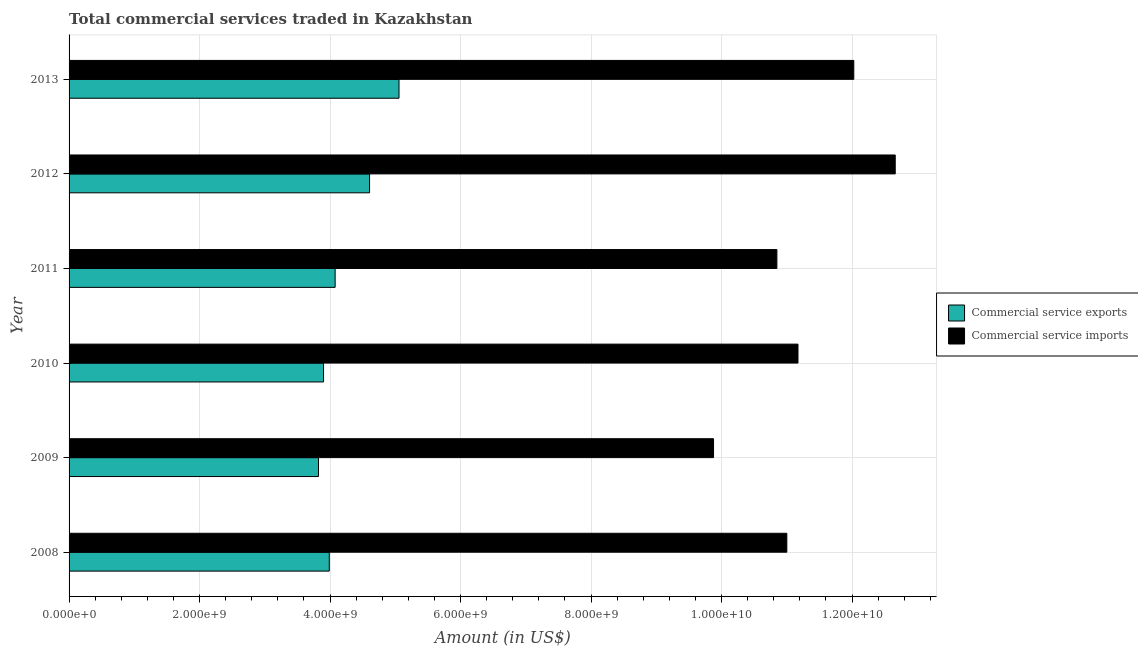In how many cases, is the number of bars for a given year not equal to the number of legend labels?
Keep it short and to the point. 0. What is the amount of commercial service exports in 2012?
Make the answer very short. 4.61e+09. Across all years, what is the maximum amount of commercial service exports?
Offer a very short reply. 5.06e+09. Across all years, what is the minimum amount of commercial service exports?
Offer a terse response. 3.82e+09. What is the total amount of commercial service imports in the graph?
Offer a very short reply. 6.76e+1. What is the difference between the amount of commercial service imports in 2009 and that in 2013?
Ensure brevity in your answer.  -2.15e+09. What is the difference between the amount of commercial service exports in 2008 and the amount of commercial service imports in 2012?
Provide a succinct answer. -8.67e+09. What is the average amount of commercial service exports per year?
Your response must be concise. 4.24e+09. In the year 2008, what is the difference between the amount of commercial service exports and amount of commercial service imports?
Your answer should be very brief. -7.01e+09. In how many years, is the amount of commercial service imports greater than 9600000000 US$?
Offer a terse response. 6. What is the ratio of the amount of commercial service exports in 2011 to that in 2012?
Your answer should be compact. 0.89. Is the amount of commercial service imports in 2012 less than that in 2013?
Provide a succinct answer. No. Is the difference between the amount of commercial service imports in 2008 and 2012 greater than the difference between the amount of commercial service exports in 2008 and 2012?
Make the answer very short. No. What is the difference between the highest and the second highest amount of commercial service imports?
Ensure brevity in your answer.  6.35e+08. What is the difference between the highest and the lowest amount of commercial service exports?
Offer a terse response. 1.23e+09. In how many years, is the amount of commercial service imports greater than the average amount of commercial service imports taken over all years?
Provide a short and direct response. 2. What does the 1st bar from the top in 2009 represents?
Offer a very short reply. Commercial service imports. What does the 2nd bar from the bottom in 2008 represents?
Give a very brief answer. Commercial service imports. Are all the bars in the graph horizontal?
Offer a terse response. Yes. How many years are there in the graph?
Give a very brief answer. 6. What is the difference between two consecutive major ticks on the X-axis?
Provide a succinct answer. 2.00e+09. Does the graph contain any zero values?
Provide a succinct answer. No. Where does the legend appear in the graph?
Your response must be concise. Center right. How many legend labels are there?
Provide a short and direct response. 2. What is the title of the graph?
Your answer should be very brief. Total commercial services traded in Kazakhstan. What is the label or title of the X-axis?
Your answer should be very brief. Amount (in US$). What is the Amount (in US$) of Commercial service exports in 2008?
Your response must be concise. 3.99e+09. What is the Amount (in US$) in Commercial service imports in 2008?
Provide a succinct answer. 1.10e+1. What is the Amount (in US$) of Commercial service exports in 2009?
Give a very brief answer. 3.82e+09. What is the Amount (in US$) in Commercial service imports in 2009?
Offer a very short reply. 9.88e+09. What is the Amount (in US$) in Commercial service exports in 2010?
Provide a succinct answer. 3.90e+09. What is the Amount (in US$) of Commercial service imports in 2010?
Offer a very short reply. 1.12e+1. What is the Amount (in US$) in Commercial service exports in 2011?
Make the answer very short. 4.08e+09. What is the Amount (in US$) in Commercial service imports in 2011?
Offer a terse response. 1.08e+1. What is the Amount (in US$) of Commercial service exports in 2012?
Your response must be concise. 4.61e+09. What is the Amount (in US$) of Commercial service imports in 2012?
Provide a short and direct response. 1.27e+1. What is the Amount (in US$) in Commercial service exports in 2013?
Your response must be concise. 5.06e+09. What is the Amount (in US$) of Commercial service imports in 2013?
Your answer should be compact. 1.20e+1. Across all years, what is the maximum Amount (in US$) in Commercial service exports?
Keep it short and to the point. 5.06e+09. Across all years, what is the maximum Amount (in US$) of Commercial service imports?
Your answer should be very brief. 1.27e+1. Across all years, what is the minimum Amount (in US$) in Commercial service exports?
Keep it short and to the point. 3.82e+09. Across all years, what is the minimum Amount (in US$) of Commercial service imports?
Your answer should be compact. 9.88e+09. What is the total Amount (in US$) in Commercial service exports in the graph?
Keep it short and to the point. 2.55e+1. What is the total Amount (in US$) of Commercial service imports in the graph?
Keep it short and to the point. 6.76e+1. What is the difference between the Amount (in US$) in Commercial service exports in 2008 and that in 2009?
Keep it short and to the point. 1.65e+08. What is the difference between the Amount (in US$) of Commercial service imports in 2008 and that in 2009?
Your answer should be compact. 1.12e+09. What is the difference between the Amount (in US$) in Commercial service exports in 2008 and that in 2010?
Provide a succinct answer. 8.77e+07. What is the difference between the Amount (in US$) of Commercial service imports in 2008 and that in 2010?
Your answer should be very brief. -1.71e+08. What is the difference between the Amount (in US$) in Commercial service exports in 2008 and that in 2011?
Your response must be concise. -8.99e+07. What is the difference between the Amount (in US$) in Commercial service imports in 2008 and that in 2011?
Keep it short and to the point. 1.52e+08. What is the difference between the Amount (in US$) of Commercial service exports in 2008 and that in 2012?
Your answer should be very brief. -6.18e+08. What is the difference between the Amount (in US$) of Commercial service imports in 2008 and that in 2012?
Provide a short and direct response. -1.66e+09. What is the difference between the Amount (in US$) of Commercial service exports in 2008 and that in 2013?
Offer a very short reply. -1.07e+09. What is the difference between the Amount (in US$) of Commercial service imports in 2008 and that in 2013?
Keep it short and to the point. -1.03e+09. What is the difference between the Amount (in US$) in Commercial service exports in 2009 and that in 2010?
Your answer should be very brief. -7.77e+07. What is the difference between the Amount (in US$) of Commercial service imports in 2009 and that in 2010?
Give a very brief answer. -1.29e+09. What is the difference between the Amount (in US$) in Commercial service exports in 2009 and that in 2011?
Offer a very short reply. -2.55e+08. What is the difference between the Amount (in US$) of Commercial service imports in 2009 and that in 2011?
Give a very brief answer. -9.71e+08. What is the difference between the Amount (in US$) in Commercial service exports in 2009 and that in 2012?
Your answer should be very brief. -7.83e+08. What is the difference between the Amount (in US$) in Commercial service imports in 2009 and that in 2012?
Give a very brief answer. -2.78e+09. What is the difference between the Amount (in US$) in Commercial service exports in 2009 and that in 2013?
Offer a very short reply. -1.23e+09. What is the difference between the Amount (in US$) in Commercial service imports in 2009 and that in 2013?
Make the answer very short. -2.15e+09. What is the difference between the Amount (in US$) in Commercial service exports in 2010 and that in 2011?
Your answer should be compact. -1.78e+08. What is the difference between the Amount (in US$) in Commercial service imports in 2010 and that in 2011?
Keep it short and to the point. 3.23e+08. What is the difference between the Amount (in US$) in Commercial service exports in 2010 and that in 2012?
Offer a terse response. -7.05e+08. What is the difference between the Amount (in US$) in Commercial service imports in 2010 and that in 2012?
Your answer should be very brief. -1.49e+09. What is the difference between the Amount (in US$) of Commercial service exports in 2010 and that in 2013?
Provide a succinct answer. -1.16e+09. What is the difference between the Amount (in US$) in Commercial service imports in 2010 and that in 2013?
Provide a short and direct response. -8.55e+08. What is the difference between the Amount (in US$) of Commercial service exports in 2011 and that in 2012?
Keep it short and to the point. -5.28e+08. What is the difference between the Amount (in US$) of Commercial service imports in 2011 and that in 2012?
Keep it short and to the point. -1.81e+09. What is the difference between the Amount (in US$) in Commercial service exports in 2011 and that in 2013?
Offer a very short reply. -9.79e+08. What is the difference between the Amount (in US$) in Commercial service imports in 2011 and that in 2013?
Your response must be concise. -1.18e+09. What is the difference between the Amount (in US$) in Commercial service exports in 2012 and that in 2013?
Keep it short and to the point. -4.51e+08. What is the difference between the Amount (in US$) in Commercial service imports in 2012 and that in 2013?
Provide a short and direct response. 6.35e+08. What is the difference between the Amount (in US$) of Commercial service exports in 2008 and the Amount (in US$) of Commercial service imports in 2009?
Your answer should be compact. -5.89e+09. What is the difference between the Amount (in US$) in Commercial service exports in 2008 and the Amount (in US$) in Commercial service imports in 2010?
Make the answer very short. -7.18e+09. What is the difference between the Amount (in US$) in Commercial service exports in 2008 and the Amount (in US$) in Commercial service imports in 2011?
Give a very brief answer. -6.86e+09. What is the difference between the Amount (in US$) of Commercial service exports in 2008 and the Amount (in US$) of Commercial service imports in 2012?
Your response must be concise. -8.67e+09. What is the difference between the Amount (in US$) of Commercial service exports in 2008 and the Amount (in US$) of Commercial service imports in 2013?
Offer a very short reply. -8.04e+09. What is the difference between the Amount (in US$) in Commercial service exports in 2009 and the Amount (in US$) in Commercial service imports in 2010?
Provide a succinct answer. -7.35e+09. What is the difference between the Amount (in US$) of Commercial service exports in 2009 and the Amount (in US$) of Commercial service imports in 2011?
Ensure brevity in your answer.  -7.03e+09. What is the difference between the Amount (in US$) in Commercial service exports in 2009 and the Amount (in US$) in Commercial service imports in 2012?
Your answer should be compact. -8.84e+09. What is the difference between the Amount (in US$) of Commercial service exports in 2009 and the Amount (in US$) of Commercial service imports in 2013?
Your answer should be very brief. -8.20e+09. What is the difference between the Amount (in US$) in Commercial service exports in 2010 and the Amount (in US$) in Commercial service imports in 2011?
Offer a terse response. -6.95e+09. What is the difference between the Amount (in US$) of Commercial service exports in 2010 and the Amount (in US$) of Commercial service imports in 2012?
Make the answer very short. -8.76e+09. What is the difference between the Amount (in US$) in Commercial service exports in 2010 and the Amount (in US$) in Commercial service imports in 2013?
Give a very brief answer. -8.13e+09. What is the difference between the Amount (in US$) in Commercial service exports in 2011 and the Amount (in US$) in Commercial service imports in 2012?
Give a very brief answer. -8.58e+09. What is the difference between the Amount (in US$) in Commercial service exports in 2011 and the Amount (in US$) in Commercial service imports in 2013?
Your answer should be very brief. -7.95e+09. What is the difference between the Amount (in US$) of Commercial service exports in 2012 and the Amount (in US$) of Commercial service imports in 2013?
Ensure brevity in your answer.  -7.42e+09. What is the average Amount (in US$) in Commercial service exports per year?
Offer a very short reply. 4.24e+09. What is the average Amount (in US$) of Commercial service imports per year?
Your response must be concise. 1.13e+1. In the year 2008, what is the difference between the Amount (in US$) in Commercial service exports and Amount (in US$) in Commercial service imports?
Your answer should be compact. -7.01e+09. In the year 2009, what is the difference between the Amount (in US$) in Commercial service exports and Amount (in US$) in Commercial service imports?
Keep it short and to the point. -6.05e+09. In the year 2010, what is the difference between the Amount (in US$) in Commercial service exports and Amount (in US$) in Commercial service imports?
Offer a terse response. -7.27e+09. In the year 2011, what is the difference between the Amount (in US$) in Commercial service exports and Amount (in US$) in Commercial service imports?
Provide a succinct answer. -6.77e+09. In the year 2012, what is the difference between the Amount (in US$) in Commercial service exports and Amount (in US$) in Commercial service imports?
Give a very brief answer. -8.06e+09. In the year 2013, what is the difference between the Amount (in US$) in Commercial service exports and Amount (in US$) in Commercial service imports?
Make the answer very short. -6.97e+09. What is the ratio of the Amount (in US$) of Commercial service exports in 2008 to that in 2009?
Your answer should be compact. 1.04. What is the ratio of the Amount (in US$) of Commercial service imports in 2008 to that in 2009?
Keep it short and to the point. 1.11. What is the ratio of the Amount (in US$) in Commercial service exports in 2008 to that in 2010?
Give a very brief answer. 1.02. What is the ratio of the Amount (in US$) in Commercial service imports in 2008 to that in 2010?
Offer a terse response. 0.98. What is the ratio of the Amount (in US$) of Commercial service exports in 2008 to that in 2011?
Offer a terse response. 0.98. What is the ratio of the Amount (in US$) in Commercial service imports in 2008 to that in 2011?
Ensure brevity in your answer.  1.01. What is the ratio of the Amount (in US$) in Commercial service exports in 2008 to that in 2012?
Provide a short and direct response. 0.87. What is the ratio of the Amount (in US$) in Commercial service imports in 2008 to that in 2012?
Your answer should be compact. 0.87. What is the ratio of the Amount (in US$) in Commercial service exports in 2008 to that in 2013?
Your response must be concise. 0.79. What is the ratio of the Amount (in US$) in Commercial service imports in 2008 to that in 2013?
Ensure brevity in your answer.  0.91. What is the ratio of the Amount (in US$) of Commercial service exports in 2009 to that in 2010?
Provide a succinct answer. 0.98. What is the ratio of the Amount (in US$) of Commercial service imports in 2009 to that in 2010?
Provide a short and direct response. 0.88. What is the ratio of the Amount (in US$) of Commercial service exports in 2009 to that in 2011?
Give a very brief answer. 0.94. What is the ratio of the Amount (in US$) in Commercial service imports in 2009 to that in 2011?
Keep it short and to the point. 0.91. What is the ratio of the Amount (in US$) of Commercial service exports in 2009 to that in 2012?
Your answer should be compact. 0.83. What is the ratio of the Amount (in US$) of Commercial service imports in 2009 to that in 2012?
Provide a short and direct response. 0.78. What is the ratio of the Amount (in US$) in Commercial service exports in 2009 to that in 2013?
Your answer should be compact. 0.76. What is the ratio of the Amount (in US$) in Commercial service imports in 2009 to that in 2013?
Ensure brevity in your answer.  0.82. What is the ratio of the Amount (in US$) of Commercial service exports in 2010 to that in 2011?
Provide a short and direct response. 0.96. What is the ratio of the Amount (in US$) in Commercial service imports in 2010 to that in 2011?
Your answer should be very brief. 1.03. What is the ratio of the Amount (in US$) in Commercial service exports in 2010 to that in 2012?
Keep it short and to the point. 0.85. What is the ratio of the Amount (in US$) in Commercial service imports in 2010 to that in 2012?
Your answer should be compact. 0.88. What is the ratio of the Amount (in US$) in Commercial service exports in 2010 to that in 2013?
Ensure brevity in your answer.  0.77. What is the ratio of the Amount (in US$) of Commercial service imports in 2010 to that in 2013?
Make the answer very short. 0.93. What is the ratio of the Amount (in US$) of Commercial service exports in 2011 to that in 2012?
Make the answer very short. 0.89. What is the ratio of the Amount (in US$) of Commercial service imports in 2011 to that in 2012?
Your response must be concise. 0.86. What is the ratio of the Amount (in US$) in Commercial service exports in 2011 to that in 2013?
Your answer should be very brief. 0.81. What is the ratio of the Amount (in US$) in Commercial service imports in 2011 to that in 2013?
Keep it short and to the point. 0.9. What is the ratio of the Amount (in US$) in Commercial service exports in 2012 to that in 2013?
Provide a succinct answer. 0.91. What is the ratio of the Amount (in US$) in Commercial service imports in 2012 to that in 2013?
Give a very brief answer. 1.05. What is the difference between the highest and the second highest Amount (in US$) in Commercial service exports?
Give a very brief answer. 4.51e+08. What is the difference between the highest and the second highest Amount (in US$) of Commercial service imports?
Give a very brief answer. 6.35e+08. What is the difference between the highest and the lowest Amount (in US$) in Commercial service exports?
Your response must be concise. 1.23e+09. What is the difference between the highest and the lowest Amount (in US$) in Commercial service imports?
Make the answer very short. 2.78e+09. 